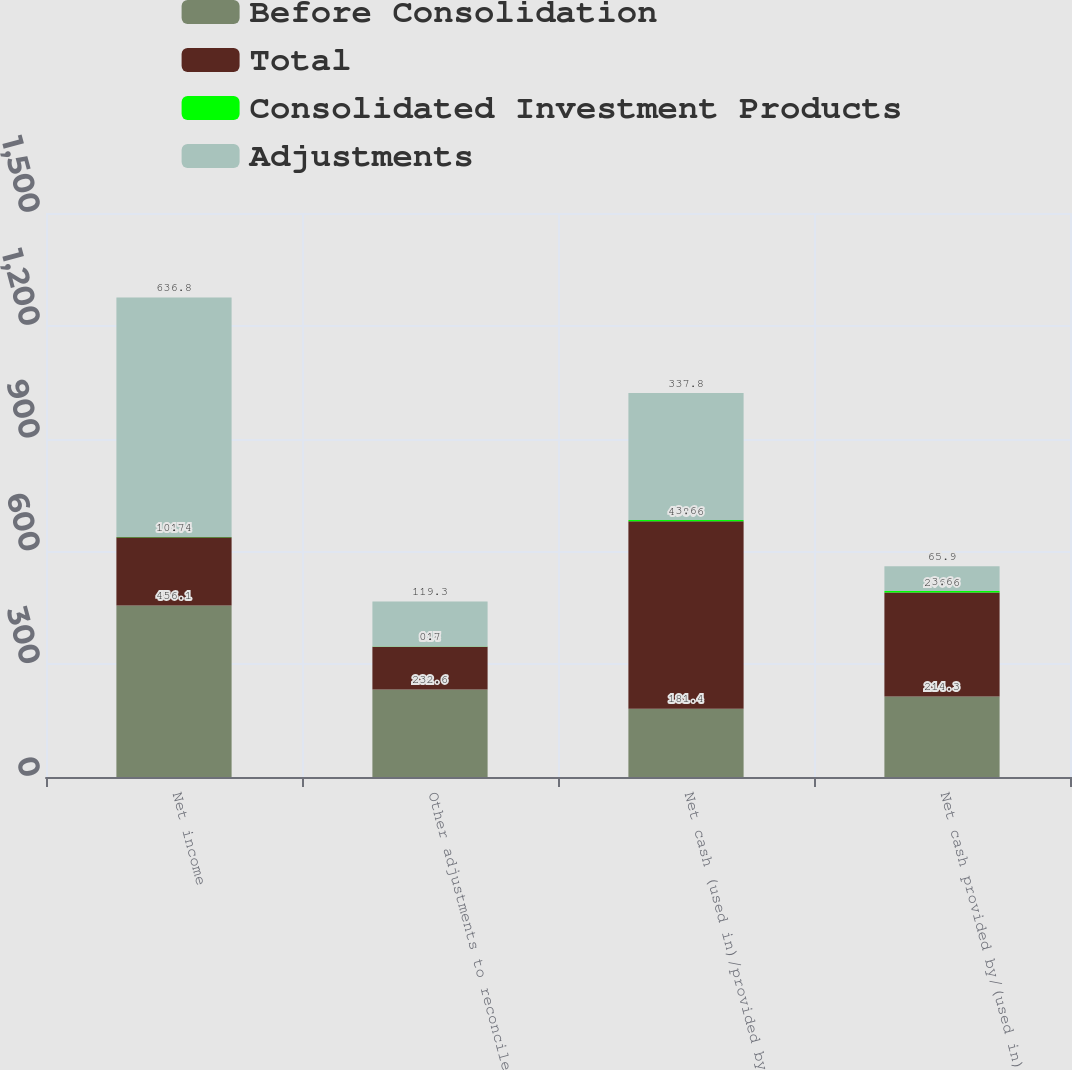Convert chart. <chart><loc_0><loc_0><loc_500><loc_500><stacked_bar_chart><ecel><fcel>Net income<fcel>Other adjustments to reconcile<fcel>Net cash (used in)/provided by<fcel>Net cash provided by/(used in)<nl><fcel>Before Consolidation<fcel>456.1<fcel>232.6<fcel>181.4<fcel>214.3<nl><fcel>Total<fcel>181.4<fcel>114<fcel>498.6<fcel>276.6<nl><fcel>Consolidated Investment Products<fcel>0.7<fcel>0.7<fcel>3.6<fcel>3.6<nl><fcel>Adjustments<fcel>636.8<fcel>119.3<fcel>337.8<fcel>65.9<nl></chart> 